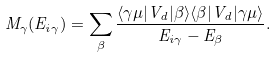<formula> <loc_0><loc_0><loc_500><loc_500>M _ { \gamma } ( E _ { i \gamma } ) = \sum _ { \beta } \frac { \langle \gamma \mu | V _ { d } | \beta \rangle \langle \beta | V _ { d } | \gamma \mu \rangle } { E _ { i \gamma } - E _ { \beta } } .</formula> 